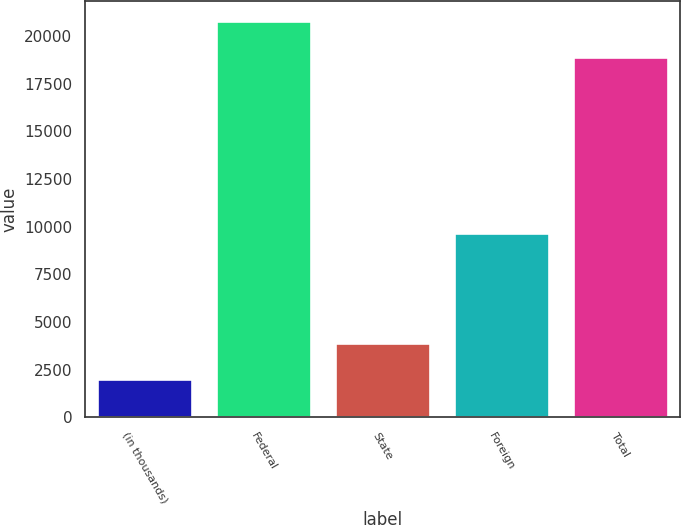Convert chart. <chart><loc_0><loc_0><loc_500><loc_500><bar_chart><fcel>(in thousands)<fcel>Federal<fcel>State<fcel>Foreign<fcel>Total<nl><fcel>2006<fcel>20772.7<fcel>3873.7<fcel>9686<fcel>18905<nl></chart> 